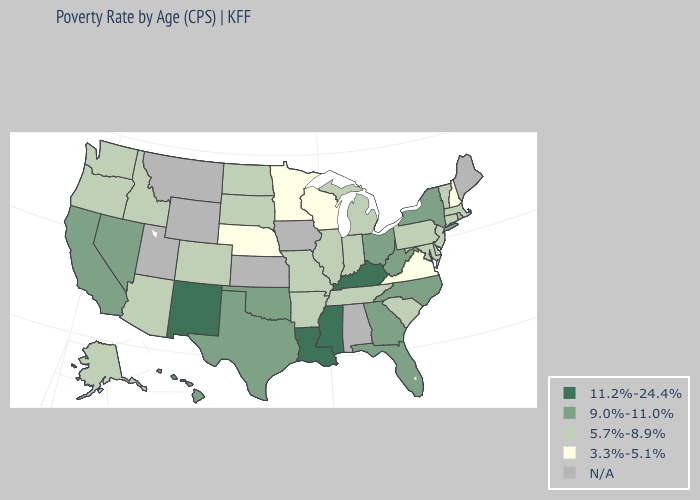What is the value of Washington?
Give a very brief answer. 5.7%-8.9%. Which states have the lowest value in the USA?
Concise answer only. Minnesota, Nebraska, New Hampshire, Virginia, Wisconsin. What is the value of Nebraska?
Quick response, please. 3.3%-5.1%. Does the map have missing data?
Concise answer only. Yes. Name the states that have a value in the range 3.3%-5.1%?
Give a very brief answer. Minnesota, Nebraska, New Hampshire, Virginia, Wisconsin. What is the highest value in the USA?
Write a very short answer. 11.2%-24.4%. Name the states that have a value in the range 3.3%-5.1%?
Write a very short answer. Minnesota, Nebraska, New Hampshire, Virginia, Wisconsin. Among the states that border Nevada , which have the highest value?
Answer briefly. California. Does South Carolina have the highest value in the South?
Short answer required. No. Does Nevada have the highest value in the USA?
Answer briefly. No. Which states have the lowest value in the USA?
Short answer required. Minnesota, Nebraska, New Hampshire, Virginia, Wisconsin. Does the first symbol in the legend represent the smallest category?
Short answer required. No. 